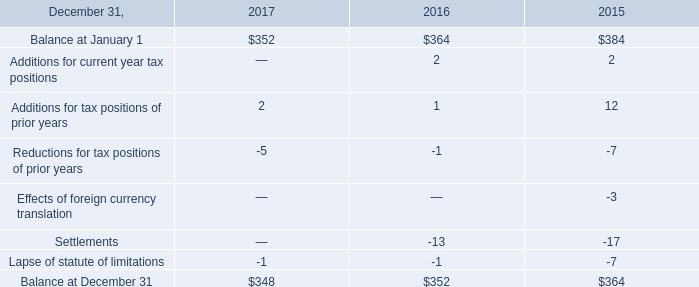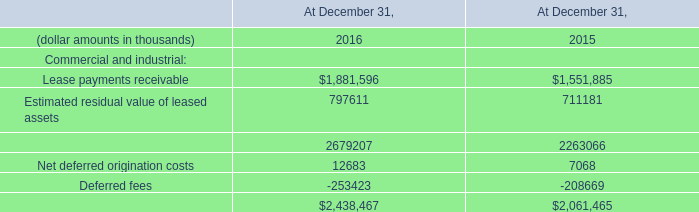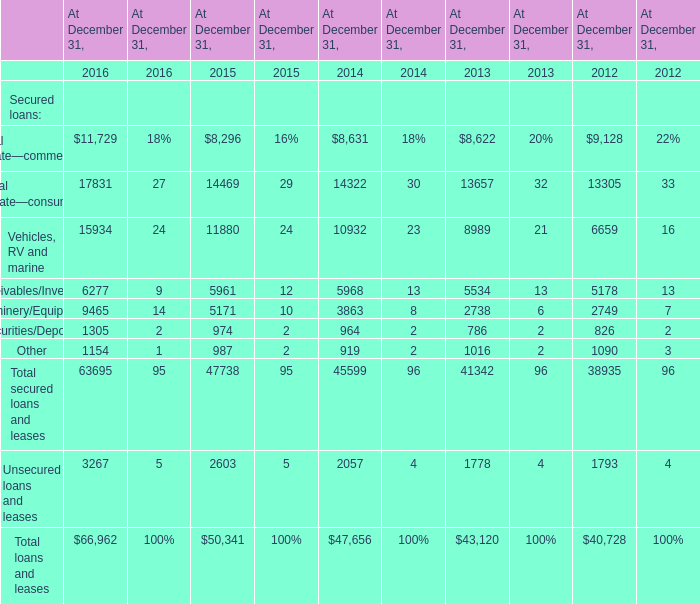what's the total amount of Real estate—consumer of At December 31, 2016, and Net deferred origination costs of At December 31, 2016 ? 
Computations: (17831.0 + 12683.0)
Answer: 30514.0. 